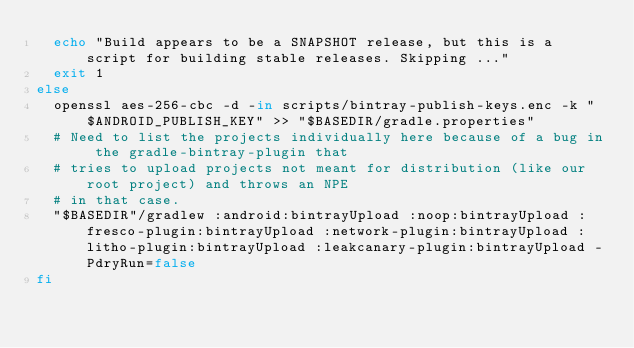<code> <loc_0><loc_0><loc_500><loc_500><_Bash_>  echo "Build appears to be a SNAPSHOT release, but this is a script for building stable releases. Skipping ..."
  exit 1
else
  openssl aes-256-cbc -d -in scripts/bintray-publish-keys.enc -k "$ANDROID_PUBLISH_KEY" >> "$BASEDIR/gradle.properties"
  # Need to list the projects individually here because of a bug in the gradle-bintray-plugin that
  # tries to upload projects not meant for distribution (like our root project) and throws an NPE
  # in that case.
  "$BASEDIR"/gradlew :android:bintrayUpload :noop:bintrayUpload :fresco-plugin:bintrayUpload :network-plugin:bintrayUpload :litho-plugin:bintrayUpload :leakcanary-plugin:bintrayUpload -PdryRun=false
fi
</code> 